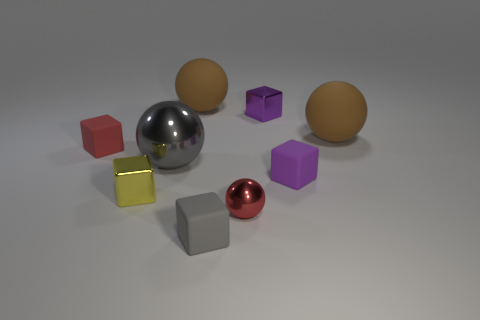The big matte thing that is on the left side of the purple matte thing is what color?
Make the answer very short. Brown. Is there a tiny purple metal thing that has the same shape as the big gray shiny object?
Your answer should be compact. No. What is the material of the large gray sphere?
Ensure brevity in your answer.  Metal. What is the size of the metallic thing that is both behind the small yellow cube and on the right side of the gray rubber block?
Your answer should be very brief. Small. What is the material of the cube that is the same color as the small ball?
Your answer should be very brief. Rubber. What number of matte blocks are there?
Offer a very short reply. 3. Is the number of red blocks less than the number of green shiny spheres?
Give a very brief answer. No. What material is the red thing that is the same size as the red shiny sphere?
Keep it short and to the point. Rubber. What number of things are yellow metal objects or tiny objects?
Provide a short and direct response. 6. What number of rubber things are behind the small red rubber cube and in front of the gray metal object?
Make the answer very short. 0. 